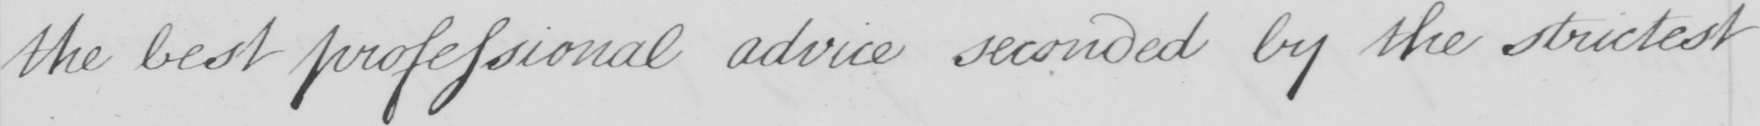What does this handwritten line say? the best professional advice seconded by the strictest 